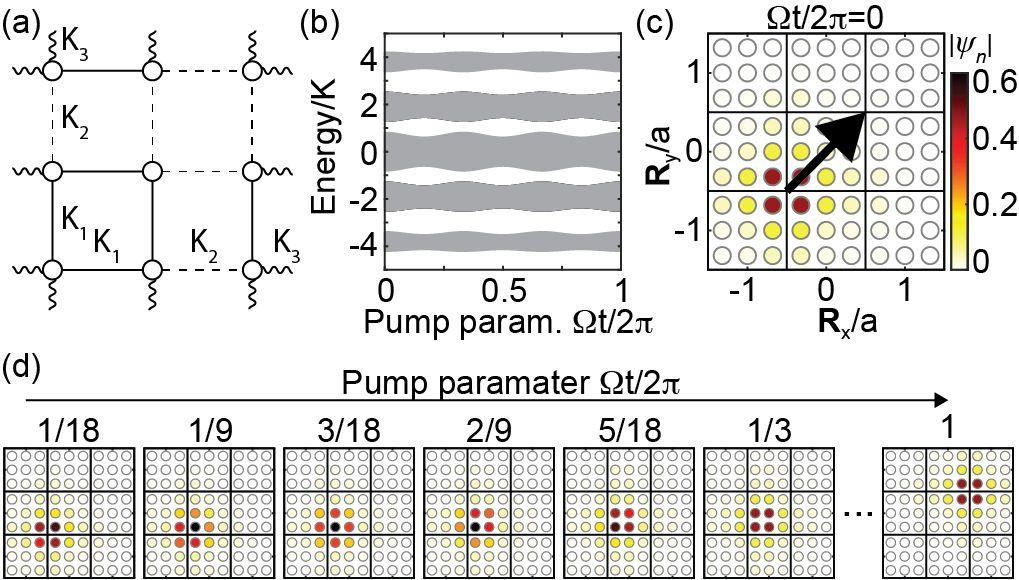Which subfigure indicates a relationship between energy and pump parameter? A. Subfigure (a) B. Subfigure (b) C. Subfigure (c) D. Subfigure (d) Subfigure (b) shows a graph with 'Energy/K' on the vertical axis and 'Pump param. Ωt/2π' on the horizontal axis. This suggests that it is showing the relationship between the energy levels of the system and the pump parameter. Therefore, the correct answer is B. 